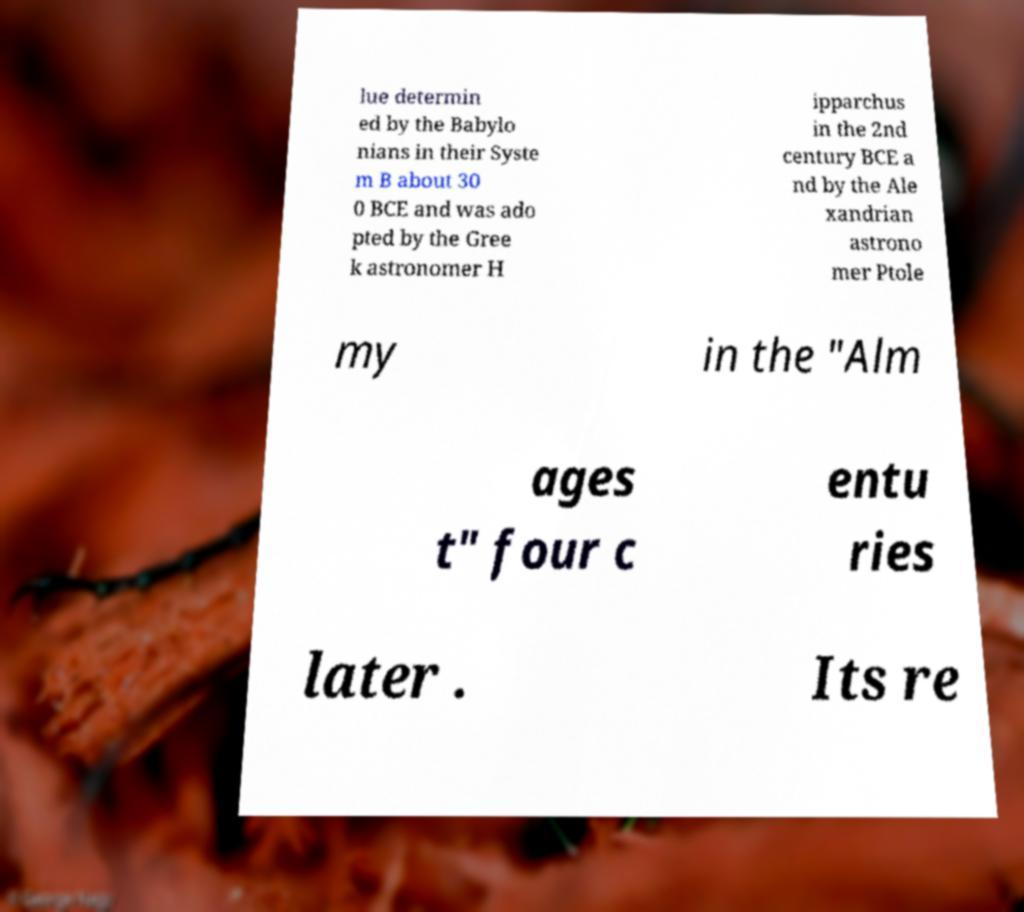Please read and relay the text visible in this image. What does it say? lue determin ed by the Babylo nians in their Syste m B about 30 0 BCE and was ado pted by the Gree k astronomer H ipparchus in the 2nd century BCE a nd by the Ale xandrian astrono mer Ptole my in the "Alm ages t" four c entu ries later . Its re 